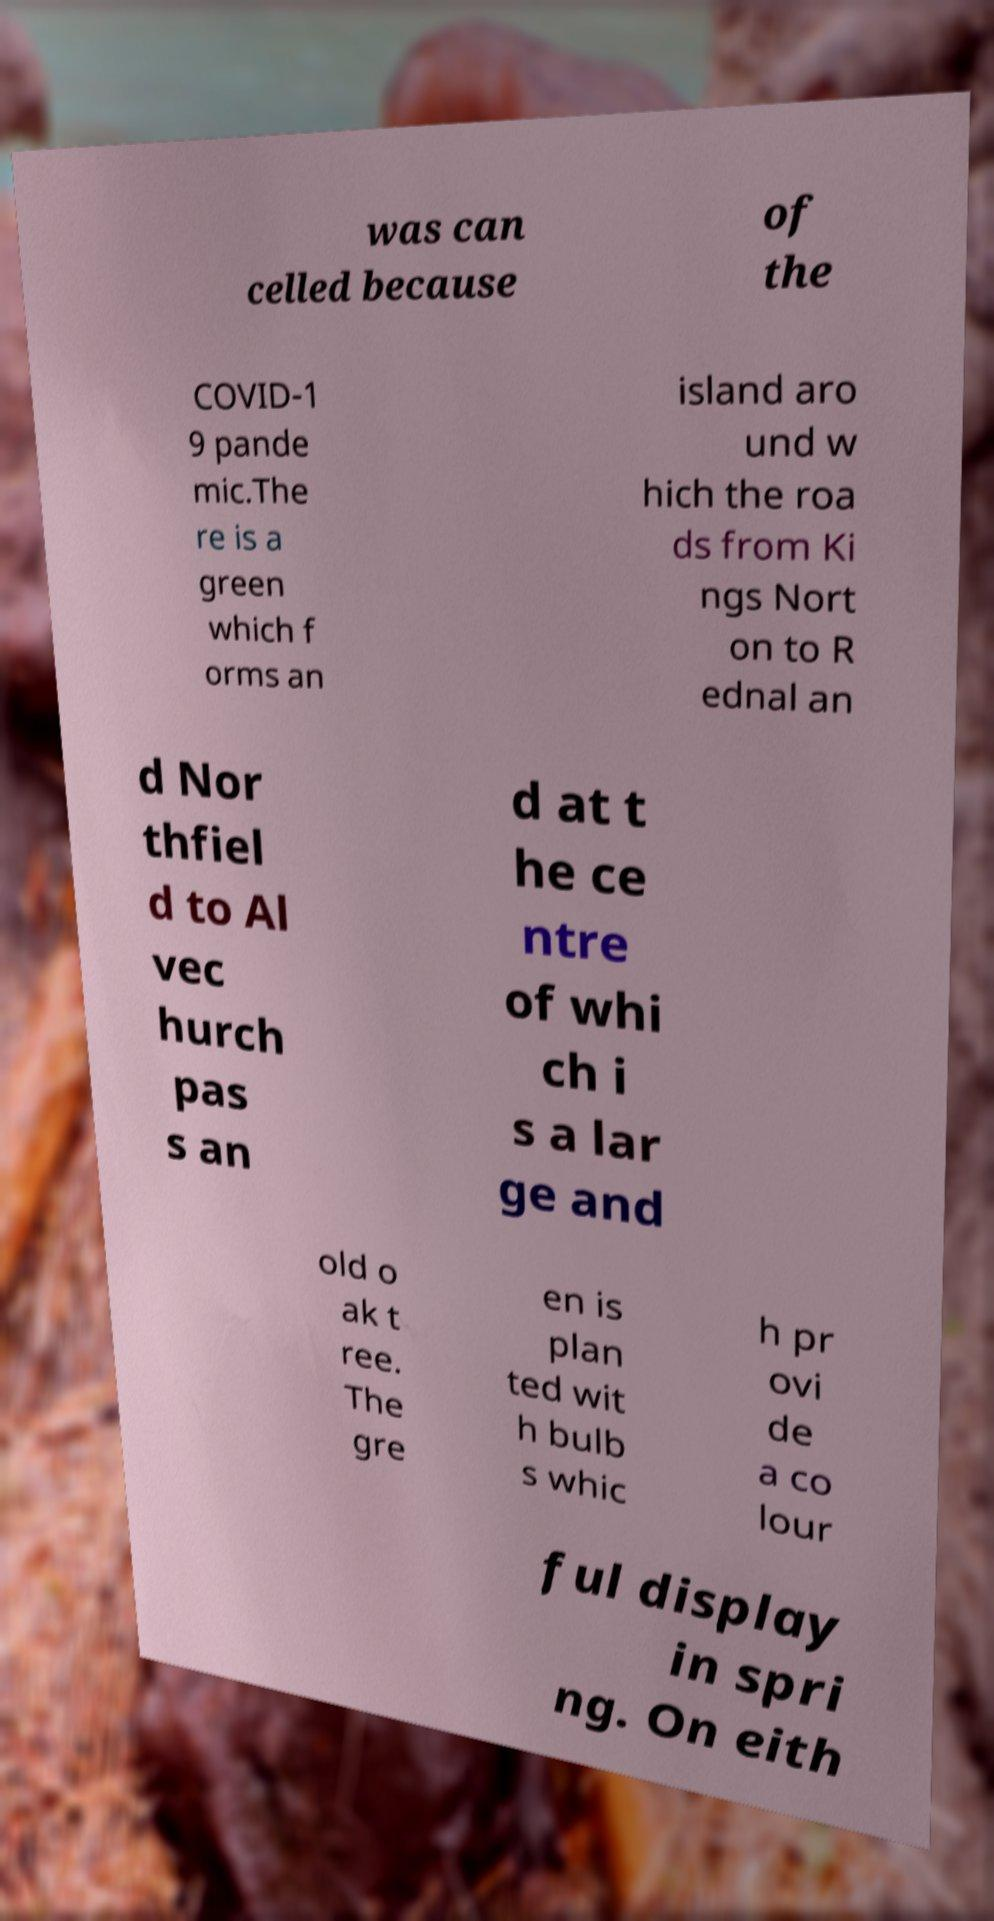What messages or text are displayed in this image? I need them in a readable, typed format. was can celled because of the COVID-1 9 pande mic.The re is a green which f orms an island aro und w hich the roa ds from Ki ngs Nort on to R ednal an d Nor thfiel d to Al vec hurch pas s an d at t he ce ntre of whi ch i s a lar ge and old o ak t ree. The gre en is plan ted wit h bulb s whic h pr ovi de a co lour ful display in spri ng. On eith 